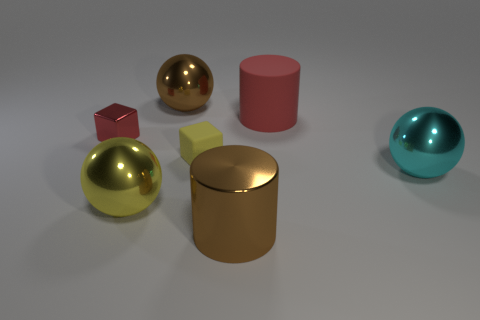How many other objects are the same material as the large cyan sphere?
Your answer should be compact. 4. There is a brown object behind the brown cylinder; what number of red objects are left of it?
Offer a very short reply. 1. How many cylinders are large brown objects or rubber objects?
Ensure brevity in your answer.  2. There is a metallic object that is both behind the big cyan ball and on the right side of the tiny red shiny object; what is its color?
Your response must be concise. Brown. What is the color of the tiny object behind the small thing that is to the right of the large brown ball?
Keep it short and to the point. Red. Do the red metal cube and the red matte thing have the same size?
Your response must be concise. No. Is the material of the large brown object behind the brown cylinder the same as the cylinder that is in front of the big rubber cylinder?
Your response must be concise. Yes. There is a thing behind the cylinder that is behind the large ball that is on the right side of the big brown shiny cylinder; what is its shape?
Your response must be concise. Sphere. Are there more yellow rubber things than tiny blue metal blocks?
Make the answer very short. Yes. Are any large blue shiny cubes visible?
Offer a very short reply. No. 